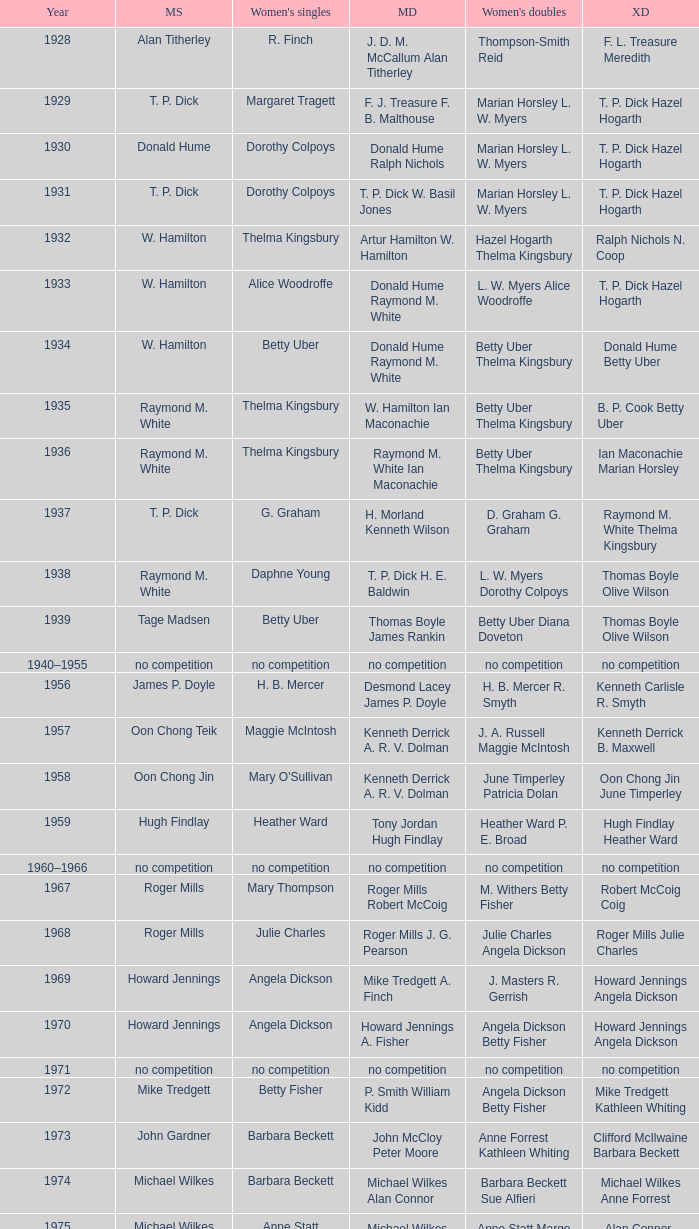Who won the Women's doubles in the year that Billy Gilliland Karen Puttick won the Mixed doubles? Jane Webster Karen Puttick. 